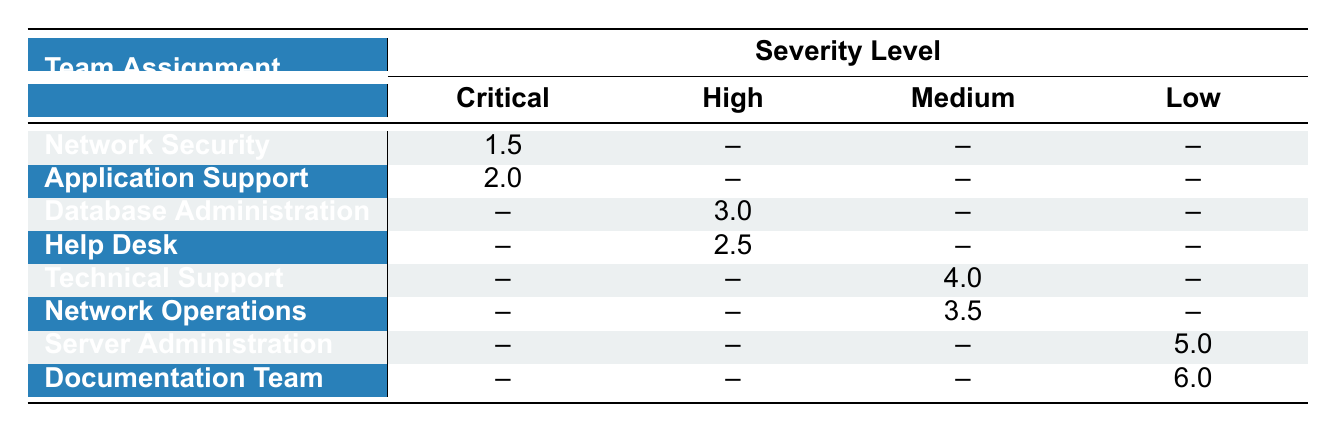What is the incident response time for the Network Security team at the Critical severity level? The table indicates that the Network Security team has an incident response time of 1.5 hours for Critical severity incidents.
Answer: 1.5 hours Which IT team has the fastest response time for Critical severity incidents? Reviewing the table, the Network Security team has the fastest response time of 1.5 hours for Critical severity incidents, compared to Application Support which has a response time of 2.0 hours.
Answer: Network Security What is the average incident response time for High severity incidents? The response times for High severity incidents are 3.0 hours (Database Administration) and 2.5 hours (Help Desk). To find the average, we sum these values: 3.0 + 2.5 = 5.5, then divide by 2: 5.5 / 2 = 2.75 hours.
Answer: 2.75 hours Is there any IT team that handles Low severity incidents? Yes, there are two teams listed that handle Low severity incidents: Server Administration with 5.0 hours and Documentation Team with 6.0 hours.
Answer: Yes Which team has the highest incident response time for Medium severity incidents? The Technical Support team has an incident response time of 4.0 hours and the Network Operations team has a response time of 3.5 hours. Therefore, the highest response time for Medium severity incidents is from Technical Support at 4.0 hours.
Answer: Technical Support What is the difference in incident response time between the Critical and Low severity for the Server Administration team? The Server Administration team does not have Critical severity listed, but has a Low severity response time of 5.0 hours. Since there's no Critical time, the difference cannot be calculated. Therefore, the difference is not applicable.
Answer: Not applicable What is the total incident response time for all teams responding to Medium severity incidents? The response times for Medium severity incidents are from Technical Support (4.0 hours) and Network Operations (3.5 hours). Adding these together, we find: 4.0 + 3.5 = 7.5 hours for all Medium severity incidents.
Answer: 7.5 hours Is the incident response time for help desk higher than that of network operations in Medium severity? For Medium severity, Help Desk is not listed. Only Technical Support (4.0 hours) and Network Operations (3.5 hours) are listed, making the Help Desk comparison not applicable.
Answer: Not applicable 